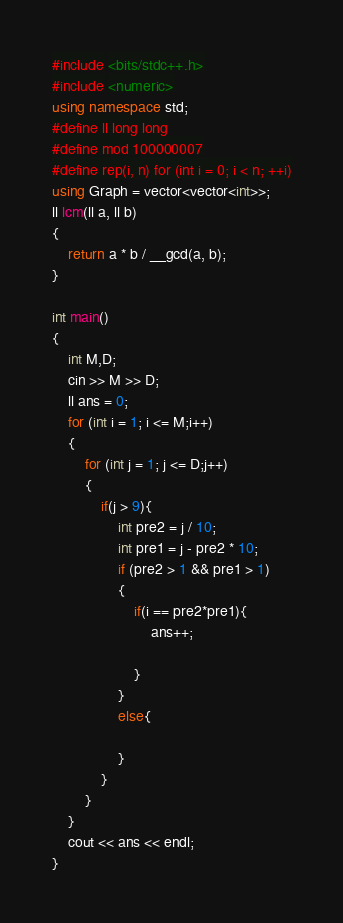<code> <loc_0><loc_0><loc_500><loc_500><_C++_>#include <bits/stdc++.h>
#include <numeric>
using namespace std;
#define ll long long
#define mod 100000007
#define rep(i, n) for (int i = 0; i < n; ++i)
using Graph = vector<vector<int>>;
ll lcm(ll a, ll b)
{
    return a * b / __gcd(a, b);
}

int main()
{
    int M,D;
    cin >> M >> D;
    ll ans = 0;
    for (int i = 1; i <= M;i++)
    {
        for (int j = 1; j <= D;j++)
        {
            if(j > 9){
                int pre2 = j / 10;
                int pre1 = j - pre2 * 10;
                if (pre2 > 1 && pre1 > 1)
                {
                    if(i == pre2*pre1){
                        ans++;

                    }
                }
                else{

                }
            }
        }
    }
    cout << ans << endl;
}</code> 